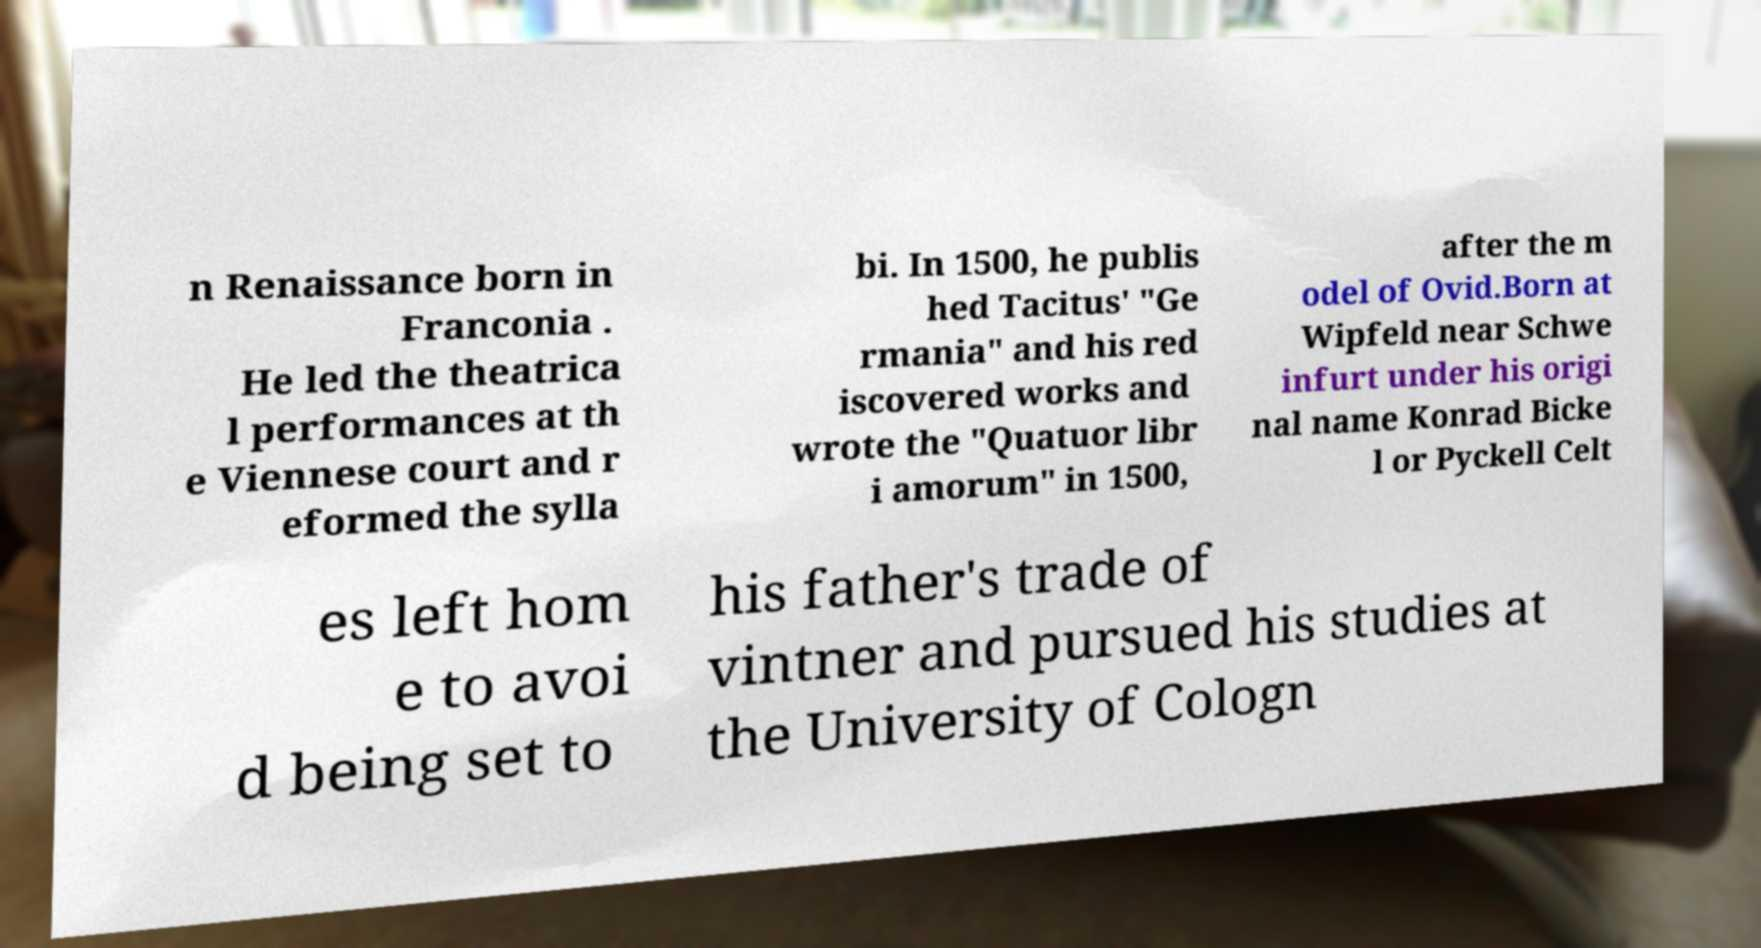Can you accurately transcribe the text from the provided image for me? n Renaissance born in Franconia . He led the theatrica l performances at th e Viennese court and r eformed the sylla bi. In 1500, he publis hed Tacitus' "Ge rmania" and his red iscovered works and wrote the "Quatuor libr i amorum" in 1500, after the m odel of Ovid.Born at Wipfeld near Schwe infurt under his origi nal name Konrad Bicke l or Pyckell Celt es left hom e to avoi d being set to his father's trade of vintner and pursued his studies at the University of Cologn 